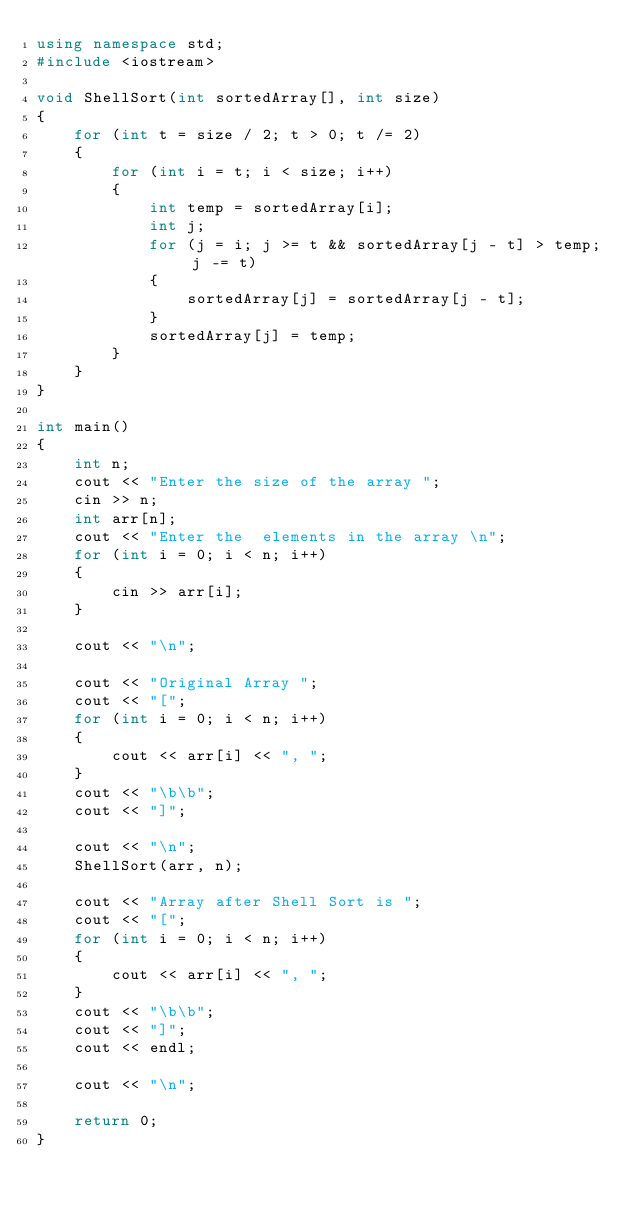Convert code to text. <code><loc_0><loc_0><loc_500><loc_500><_C++_>using namespace std;
#include <iostream>

void ShellSort(int sortedArray[], int size)
{
    for (int t = size / 2; t > 0; t /= 2)
    {
        for (int i = t; i < size; i++)
        {
            int temp = sortedArray[i];
            int j;
            for (j = i; j >= t && sortedArray[j - t] > temp; j -= t)
            {
                sortedArray[j] = sortedArray[j - t];
            }
            sortedArray[j] = temp;
        }
    }
}

int main()
{
    int n;
    cout << "Enter the size of the array ";
    cin >> n;
    int arr[n];
    cout << "Enter the  elements in the array \n";
    for (int i = 0; i < n; i++)
    {
        cin >> arr[i];
    }

    cout << "\n";

    cout << "Original Array ";
    cout << "[";
    for (int i = 0; i < n; i++)
    {
        cout << arr[i] << ", ";
    }
    cout << "\b\b";
    cout << "]";

    cout << "\n";
    ShellSort(arr, n);

    cout << "Array after Shell Sort is ";
    cout << "[";
    for (int i = 0; i < n; i++)
    {
        cout << arr[i] << ", ";
    }
    cout << "\b\b";
    cout << "]";
    cout << endl;

    cout << "\n";

    return 0;
}</code> 